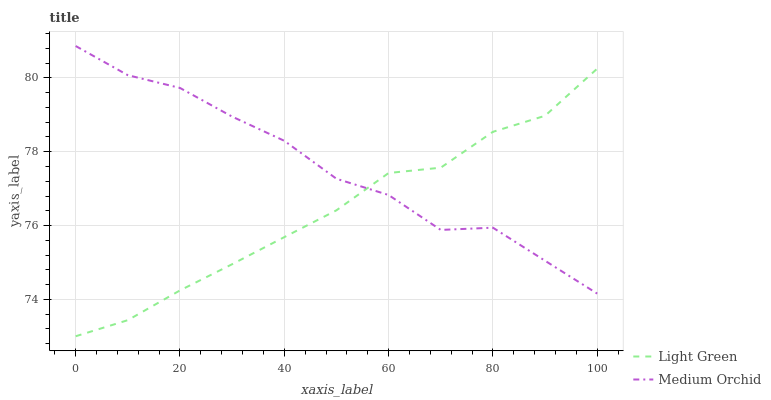Does Light Green have the minimum area under the curve?
Answer yes or no. Yes. Does Medium Orchid have the maximum area under the curve?
Answer yes or no. Yes. Does Light Green have the maximum area under the curve?
Answer yes or no. No. Is Light Green the smoothest?
Answer yes or no. Yes. Is Medium Orchid the roughest?
Answer yes or no. Yes. Is Light Green the roughest?
Answer yes or no. No. Does Light Green have the lowest value?
Answer yes or no. Yes. Does Medium Orchid have the highest value?
Answer yes or no. Yes. Does Light Green have the highest value?
Answer yes or no. No. Does Medium Orchid intersect Light Green?
Answer yes or no. Yes. Is Medium Orchid less than Light Green?
Answer yes or no. No. Is Medium Orchid greater than Light Green?
Answer yes or no. No. 